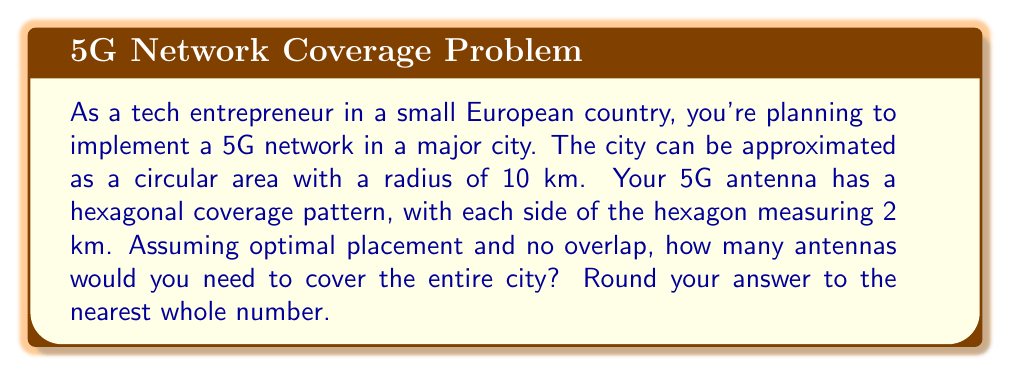Give your solution to this math problem. Let's approach this problem step by step:

1) First, we need to calculate the area of the city:
   $$A_{city} = \pi r^2 = \pi (10\text{ km})^2 = 100\pi \text{ km}^2$$

2) Next, we calculate the area of a single antenna's coverage (a regular hexagon):
   The area of a regular hexagon is given by:
   $$A_{hexagon} = \frac{3\sqrt{3}}{2}s^2$$
   where $s$ is the length of a side.

   $$A_{antenna} = \frac{3\sqrt{3}}{2}(2\text{ km})^2 = 6\sqrt{3} \text{ km}^2$$

3) To find the number of antennas needed, we divide the city area by the antenna coverage area:
   $$N_{antennas} = \frac{A_{city}}{A_{antenna}} = \frac{100\pi}{6\sqrt{3}} \approx 30.3$$

4) Rounding to the nearest whole number:
   $$N_{antennas} \approx 30$$

[asy]
unitsize(10mm);
draw(circle((0,0),3), rgb(0,0,1));
for(int i=0; i<6; ++i) {
  draw(rotate(60*i)*polygon(6), rgb(1,0,0));
}
label("City", (0,-3.5));
label("5G Antenna", (2,1));
[/asy]

The diagram shows a simplified representation of the circular city and the hexagonal coverage area of a 5G antenna.
Answer: 30 antennas 